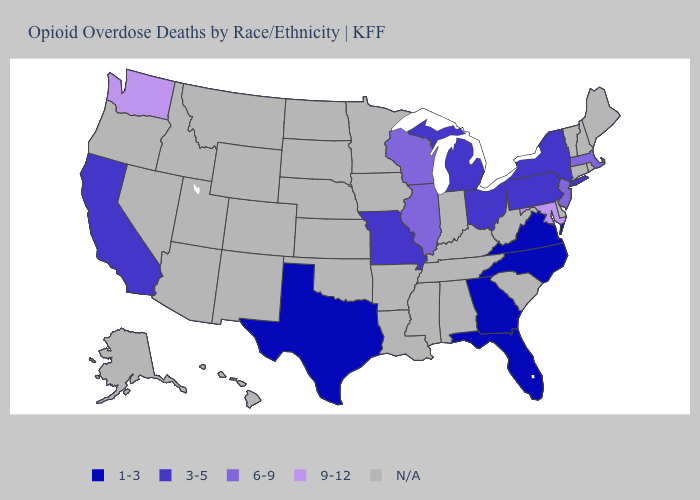Among the states that border Oklahoma , which have the highest value?
Be succinct. Missouri. Which states hav the highest value in the Northeast?
Answer briefly. Massachusetts, New Jersey. Which states have the lowest value in the West?
Keep it brief. California. Name the states that have a value in the range 3-5?
Write a very short answer. California, Michigan, Missouri, New York, Ohio, Pennsylvania. Does the first symbol in the legend represent the smallest category?
Answer briefly. Yes. Which states have the lowest value in the Northeast?
Keep it brief. New York, Pennsylvania. Does Massachusetts have the highest value in the USA?
Give a very brief answer. No. Name the states that have a value in the range 6-9?
Concise answer only. Illinois, Massachusetts, New Jersey, Wisconsin. Which states hav the highest value in the MidWest?
Keep it brief. Illinois, Wisconsin. Name the states that have a value in the range 3-5?
Answer briefly. California, Michigan, Missouri, New York, Ohio, Pennsylvania. Name the states that have a value in the range 3-5?
Keep it brief. California, Michigan, Missouri, New York, Ohio, Pennsylvania. Name the states that have a value in the range N/A?
Short answer required. Alabama, Alaska, Arizona, Arkansas, Colorado, Connecticut, Delaware, Hawaii, Idaho, Indiana, Iowa, Kansas, Kentucky, Louisiana, Maine, Minnesota, Mississippi, Montana, Nebraska, Nevada, New Hampshire, New Mexico, North Dakota, Oklahoma, Oregon, Rhode Island, South Carolina, South Dakota, Tennessee, Utah, Vermont, West Virginia, Wyoming. Which states have the lowest value in the South?
Answer briefly. Florida, Georgia, North Carolina, Texas, Virginia. 